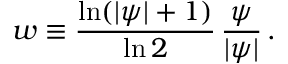Convert formula to latex. <formula><loc_0><loc_0><loc_500><loc_500>w \equiv \frac { \ln ( | \psi | + 1 ) } { \ln 2 } \, \frac { \psi } { | \psi | } \, .</formula> 